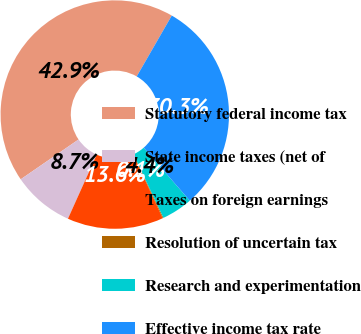Convert chart to OTSL. <chart><loc_0><loc_0><loc_500><loc_500><pie_chart><fcel>Statutory federal income tax<fcel>State income taxes (net of<fcel>Taxes on foreign earnings<fcel>Resolution of uncertain tax<fcel>Research and experimentation<fcel>Effective income tax rate<nl><fcel>42.91%<fcel>8.68%<fcel>13.61%<fcel>0.12%<fcel>4.4%<fcel>30.28%<nl></chart> 